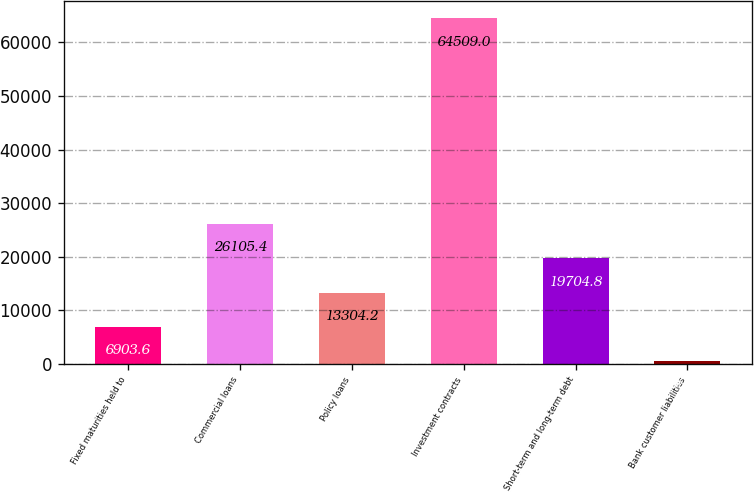Convert chart to OTSL. <chart><loc_0><loc_0><loc_500><loc_500><bar_chart><fcel>Fixed maturities held to<fcel>Commercial loans<fcel>Policy loans<fcel>Investment contracts<fcel>Short-term and long-term debt<fcel>Bank customer liabilities<nl><fcel>6903.6<fcel>26105.4<fcel>13304.2<fcel>64509<fcel>19704.8<fcel>503<nl></chart> 